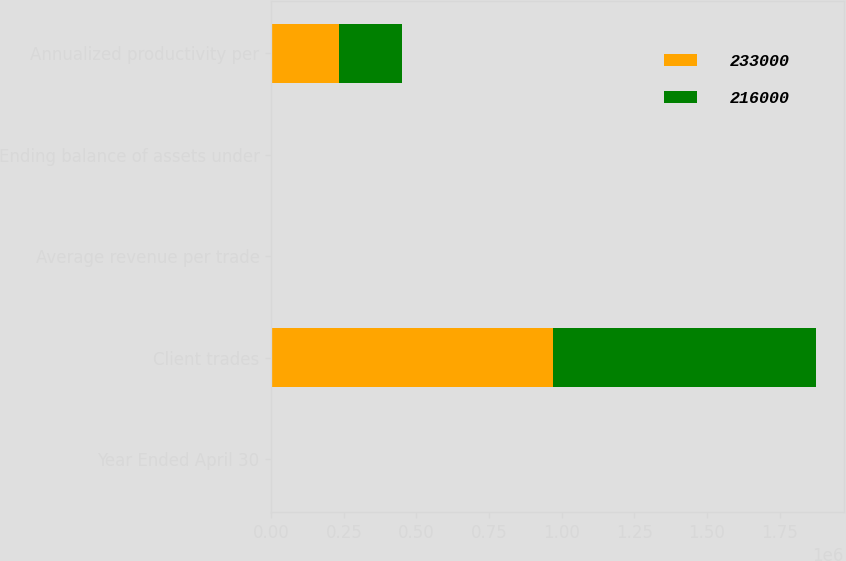Convert chart. <chart><loc_0><loc_0><loc_500><loc_500><stacked_bar_chart><ecel><fcel>Year Ended April 30<fcel>Client trades<fcel>Average revenue per trade<fcel>Ending balance of assets under<fcel>Annualized productivity per<nl><fcel>233000<fcel>2008<fcel>969364<fcel>120.22<fcel>32.1<fcel>233000<nl><fcel>216000<fcel>2007<fcel>907075<fcel>126.54<fcel>33.1<fcel>216000<nl></chart> 